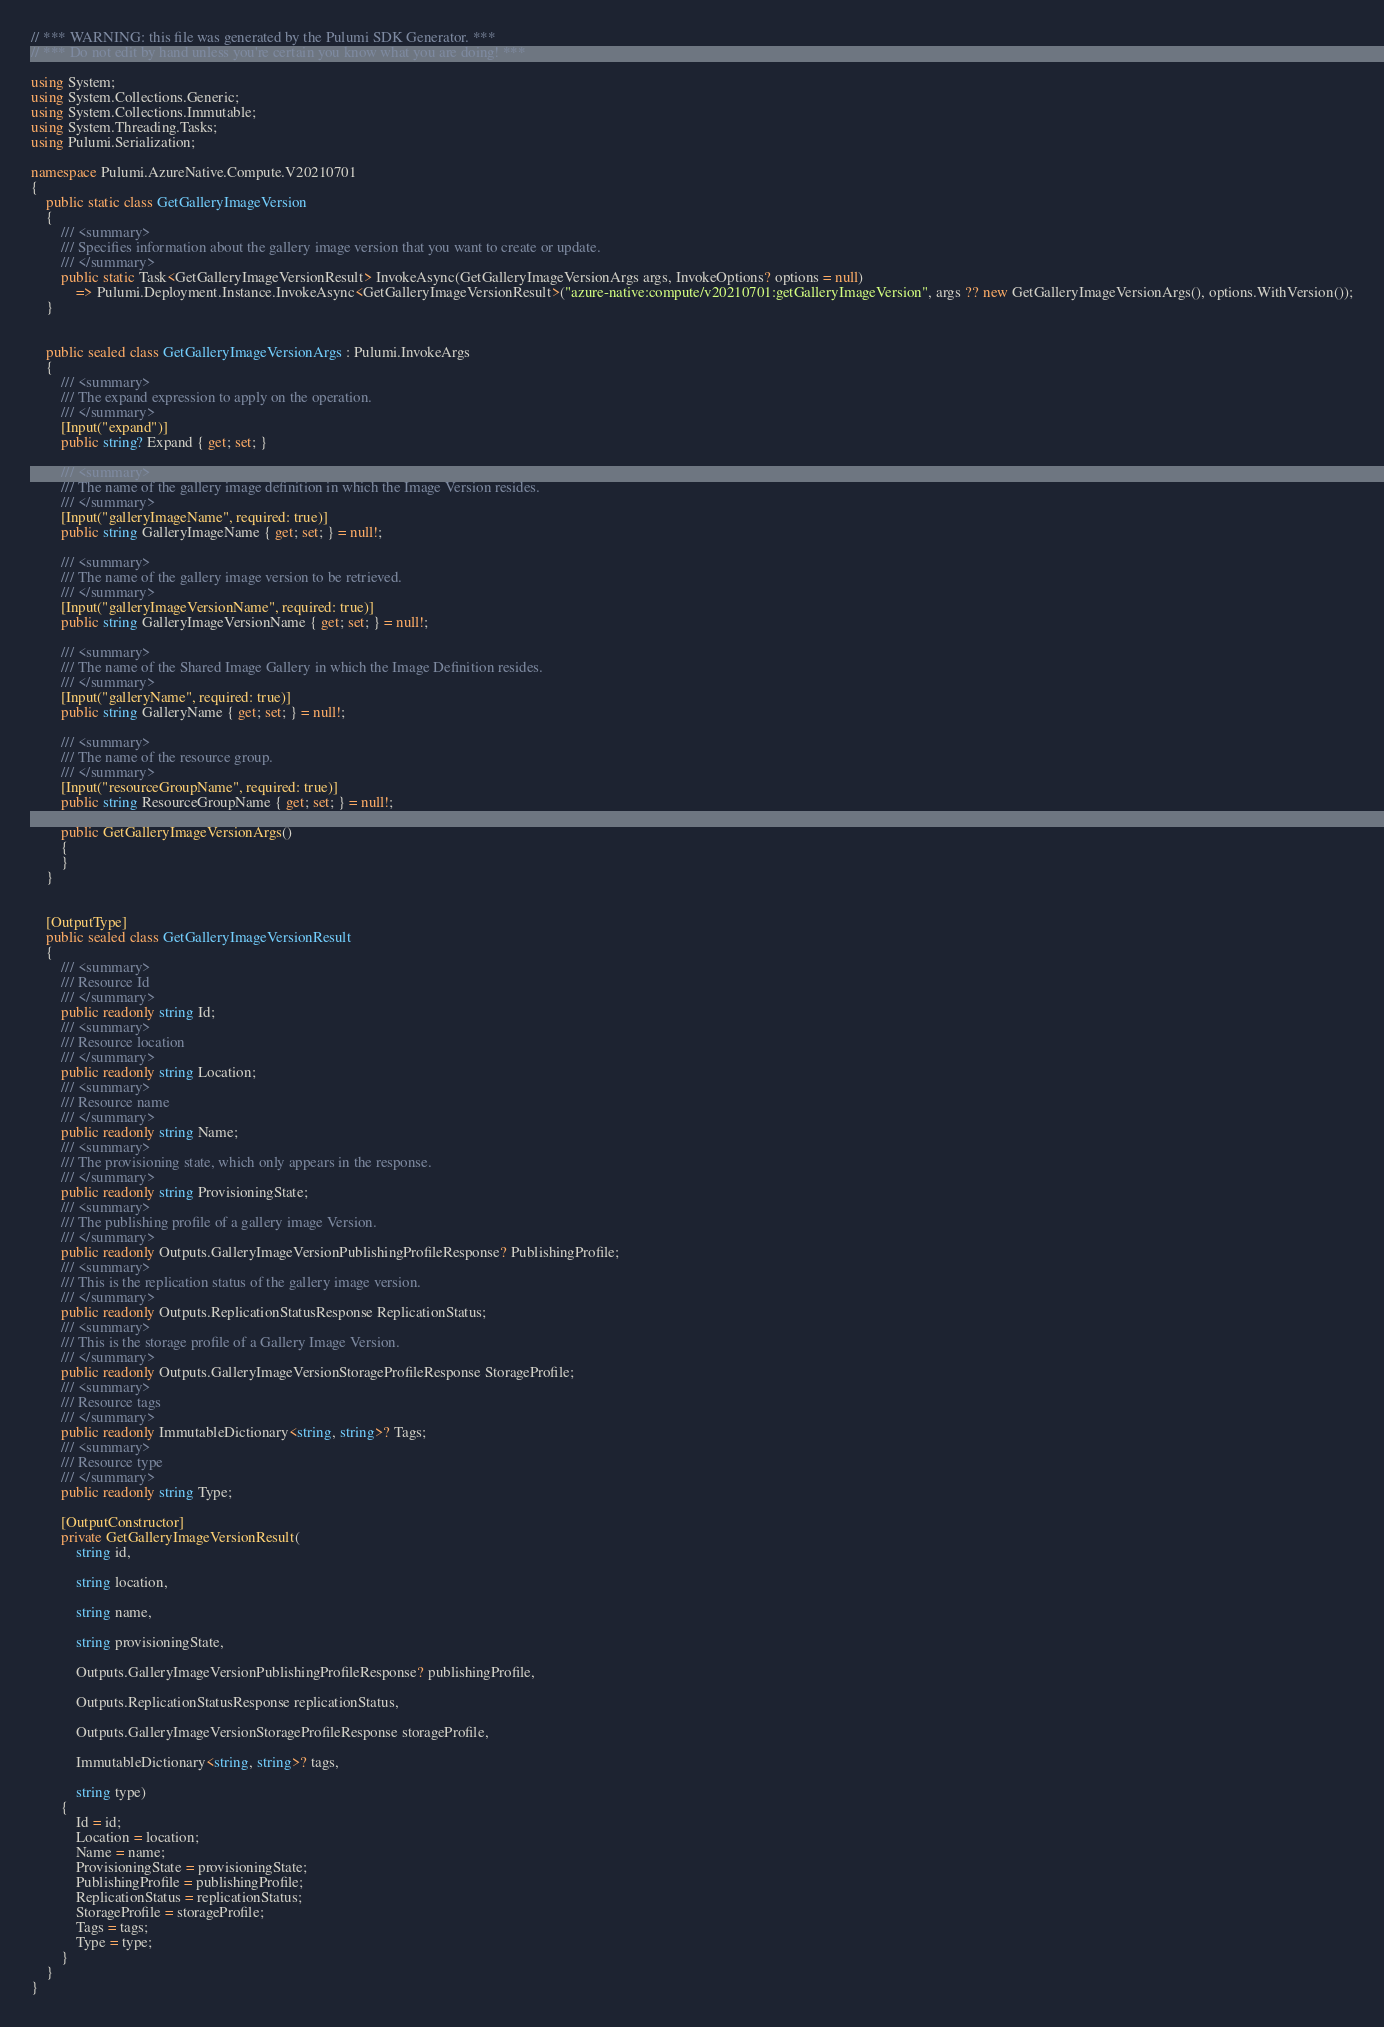<code> <loc_0><loc_0><loc_500><loc_500><_C#_>// *** WARNING: this file was generated by the Pulumi SDK Generator. ***
// *** Do not edit by hand unless you're certain you know what you are doing! ***

using System;
using System.Collections.Generic;
using System.Collections.Immutable;
using System.Threading.Tasks;
using Pulumi.Serialization;

namespace Pulumi.AzureNative.Compute.V20210701
{
    public static class GetGalleryImageVersion
    {
        /// <summary>
        /// Specifies information about the gallery image version that you want to create or update.
        /// </summary>
        public static Task<GetGalleryImageVersionResult> InvokeAsync(GetGalleryImageVersionArgs args, InvokeOptions? options = null)
            => Pulumi.Deployment.Instance.InvokeAsync<GetGalleryImageVersionResult>("azure-native:compute/v20210701:getGalleryImageVersion", args ?? new GetGalleryImageVersionArgs(), options.WithVersion());
    }


    public sealed class GetGalleryImageVersionArgs : Pulumi.InvokeArgs
    {
        /// <summary>
        /// The expand expression to apply on the operation.
        /// </summary>
        [Input("expand")]
        public string? Expand { get; set; }

        /// <summary>
        /// The name of the gallery image definition in which the Image Version resides.
        /// </summary>
        [Input("galleryImageName", required: true)]
        public string GalleryImageName { get; set; } = null!;

        /// <summary>
        /// The name of the gallery image version to be retrieved.
        /// </summary>
        [Input("galleryImageVersionName", required: true)]
        public string GalleryImageVersionName { get; set; } = null!;

        /// <summary>
        /// The name of the Shared Image Gallery in which the Image Definition resides.
        /// </summary>
        [Input("galleryName", required: true)]
        public string GalleryName { get; set; } = null!;

        /// <summary>
        /// The name of the resource group.
        /// </summary>
        [Input("resourceGroupName", required: true)]
        public string ResourceGroupName { get; set; } = null!;

        public GetGalleryImageVersionArgs()
        {
        }
    }


    [OutputType]
    public sealed class GetGalleryImageVersionResult
    {
        /// <summary>
        /// Resource Id
        /// </summary>
        public readonly string Id;
        /// <summary>
        /// Resource location
        /// </summary>
        public readonly string Location;
        /// <summary>
        /// Resource name
        /// </summary>
        public readonly string Name;
        /// <summary>
        /// The provisioning state, which only appears in the response.
        /// </summary>
        public readonly string ProvisioningState;
        /// <summary>
        /// The publishing profile of a gallery image Version.
        /// </summary>
        public readonly Outputs.GalleryImageVersionPublishingProfileResponse? PublishingProfile;
        /// <summary>
        /// This is the replication status of the gallery image version.
        /// </summary>
        public readonly Outputs.ReplicationStatusResponse ReplicationStatus;
        /// <summary>
        /// This is the storage profile of a Gallery Image Version.
        /// </summary>
        public readonly Outputs.GalleryImageVersionStorageProfileResponse StorageProfile;
        /// <summary>
        /// Resource tags
        /// </summary>
        public readonly ImmutableDictionary<string, string>? Tags;
        /// <summary>
        /// Resource type
        /// </summary>
        public readonly string Type;

        [OutputConstructor]
        private GetGalleryImageVersionResult(
            string id,

            string location,

            string name,

            string provisioningState,

            Outputs.GalleryImageVersionPublishingProfileResponse? publishingProfile,

            Outputs.ReplicationStatusResponse replicationStatus,

            Outputs.GalleryImageVersionStorageProfileResponse storageProfile,

            ImmutableDictionary<string, string>? tags,

            string type)
        {
            Id = id;
            Location = location;
            Name = name;
            ProvisioningState = provisioningState;
            PublishingProfile = publishingProfile;
            ReplicationStatus = replicationStatus;
            StorageProfile = storageProfile;
            Tags = tags;
            Type = type;
        }
    }
}
</code> 